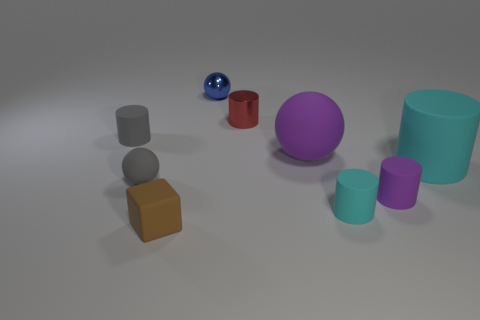Subtract all gray cylinders. How many cylinders are left? 4 Subtract all large cyan matte cylinders. How many cylinders are left? 4 Subtract 3 cylinders. How many cylinders are left? 2 Subtract all green cylinders. Subtract all green spheres. How many cylinders are left? 5 Add 1 purple rubber objects. How many objects exist? 10 Subtract all balls. How many objects are left? 6 Subtract all small cyan rubber cylinders. Subtract all big rubber cylinders. How many objects are left? 7 Add 6 small shiny balls. How many small shiny balls are left? 7 Add 4 tiny balls. How many tiny balls exist? 6 Subtract 0 blue cubes. How many objects are left? 9 